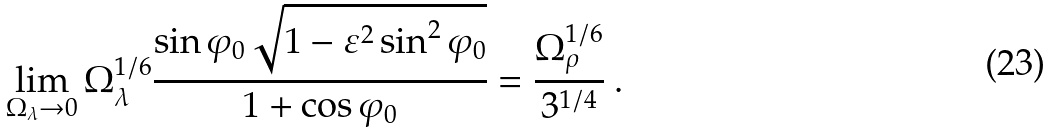<formula> <loc_0><loc_0><loc_500><loc_500>\lim _ { \Omega _ { \lambda } \rightarrow 0 } \Omega _ { \lambda } ^ { 1 / 6 } \frac { \sin \varphi _ { 0 } \sqrt { 1 - \varepsilon ^ { 2 } \sin ^ { 2 } \varphi _ { 0 } } } { 1 + \cos \varphi _ { 0 } } = \frac { \Omega _ { \rho } ^ { 1 / 6 } } { 3 ^ { 1 / 4 } } { \ } .</formula> 